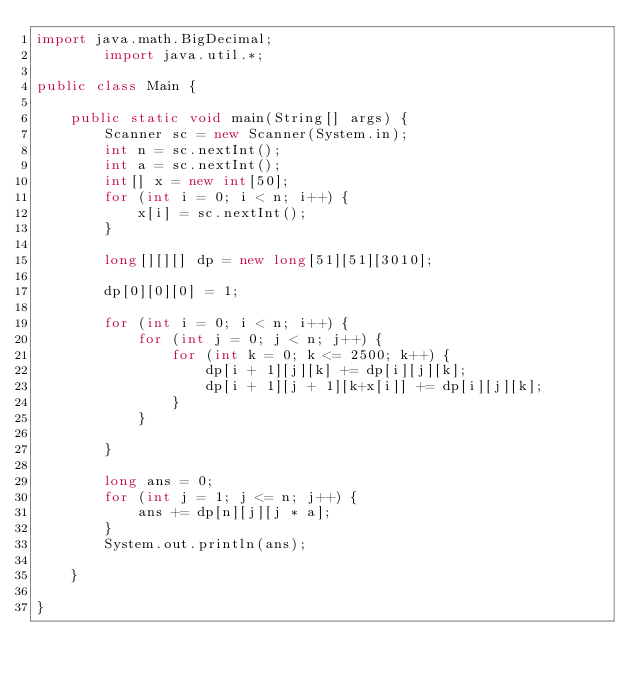<code> <loc_0><loc_0><loc_500><loc_500><_Java_>import java.math.BigDecimal;
        import java.util.*;
 
public class Main {
 
    public static void main(String[] args) {
        Scanner sc = new Scanner(System.in);
        int n = sc.nextInt();
        int a = sc.nextInt();
        int[] x = new int[50];
        for (int i = 0; i < n; i++) {
            x[i] = sc.nextInt();
        }
        
        long[][][] dp = new long[51][51][3010];
        
        dp[0][0][0] = 1;
 
        for (int i = 0; i < n; i++) {
            for (int j = 0; j < n; j++) {
                for (int k = 0; k <= 2500; k++) {
                    dp[i + 1][j][k] += dp[i][j][k];
                    dp[i + 1][j + 1][k+x[i]] += dp[i][j][k];
                }
            }
 
        }
 
        long ans = 0;
        for (int j = 1; j <= n; j++) {
            ans += dp[n][j][j * a];
        }
        System.out.println(ans);
 
    }
 
}</code> 